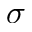Convert formula to latex. <formula><loc_0><loc_0><loc_500><loc_500>\sigma</formula> 